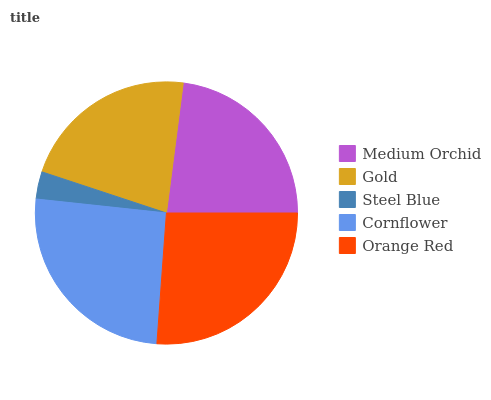Is Steel Blue the minimum?
Answer yes or no. Yes. Is Orange Red the maximum?
Answer yes or no. Yes. Is Gold the minimum?
Answer yes or no. No. Is Gold the maximum?
Answer yes or no. No. Is Medium Orchid greater than Gold?
Answer yes or no. Yes. Is Gold less than Medium Orchid?
Answer yes or no. Yes. Is Gold greater than Medium Orchid?
Answer yes or no. No. Is Medium Orchid less than Gold?
Answer yes or no. No. Is Medium Orchid the high median?
Answer yes or no. Yes. Is Medium Orchid the low median?
Answer yes or no. Yes. Is Steel Blue the high median?
Answer yes or no. No. Is Orange Red the low median?
Answer yes or no. No. 